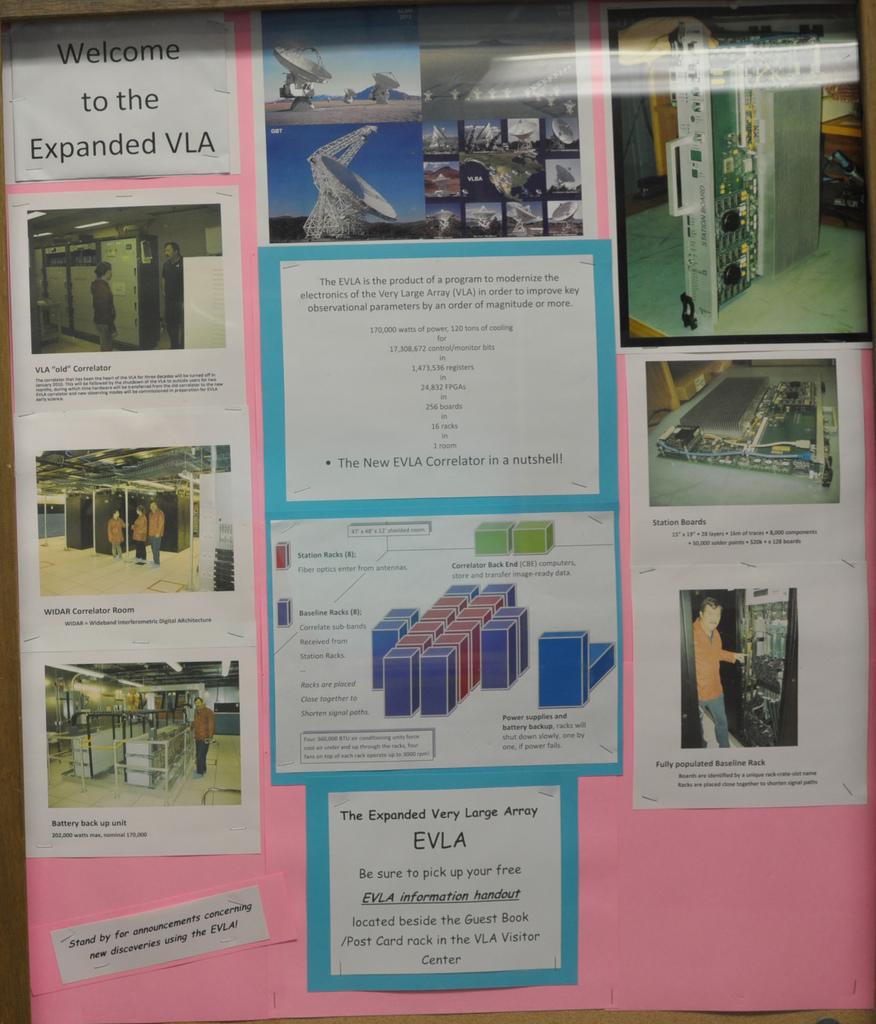What is this?
Provide a short and direct response. A bulletin board. 